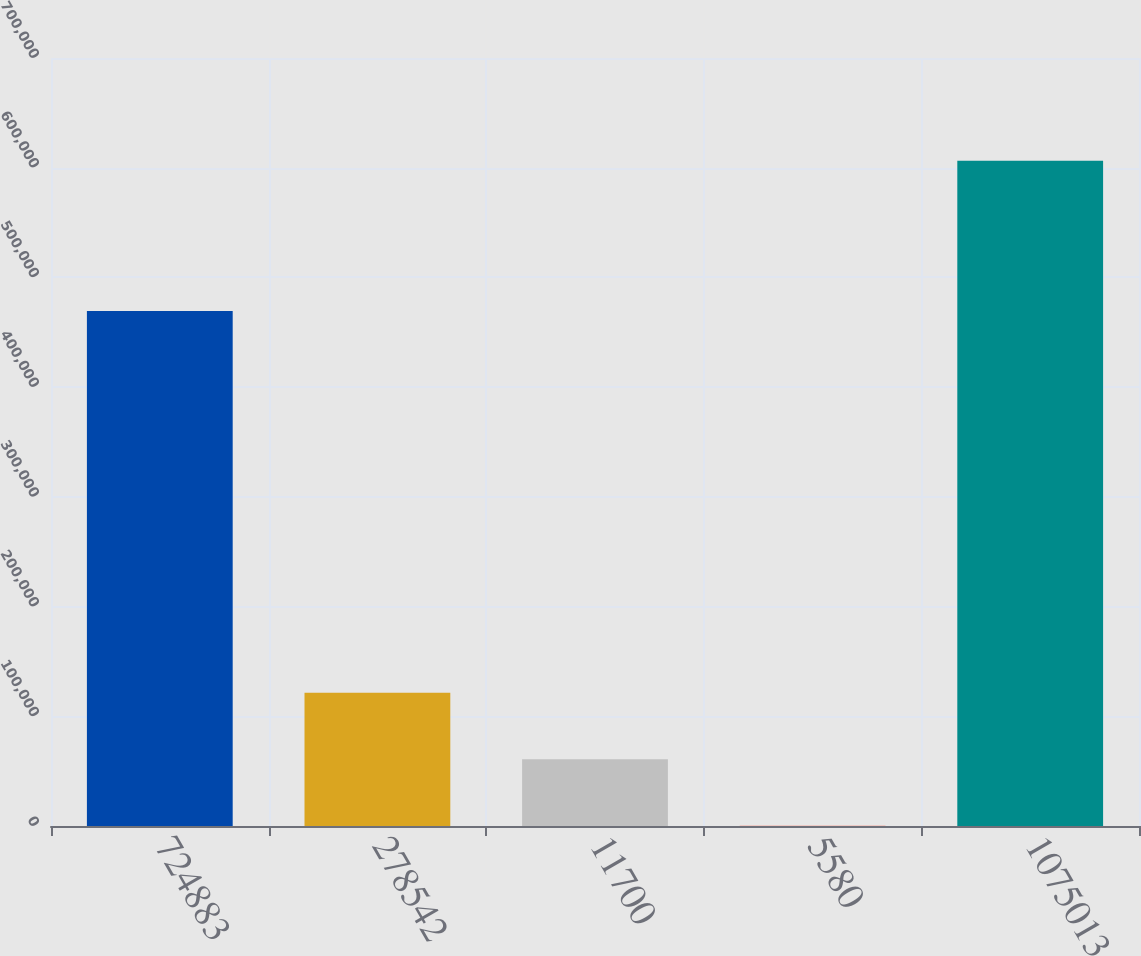Convert chart to OTSL. <chart><loc_0><loc_0><loc_500><loc_500><bar_chart><fcel>724883<fcel>278542<fcel>11700<fcel>5580<fcel>1075013<nl><fcel>469423<fcel>121492<fcel>60885.1<fcel>278<fcel>606349<nl></chart> 